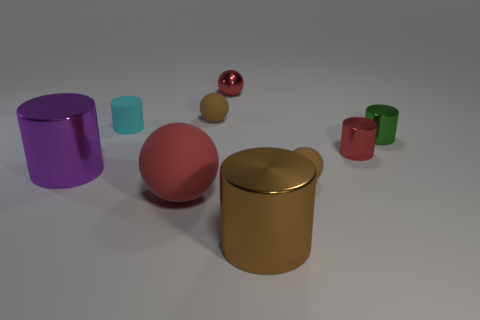Is there any other thing that is the same size as the green cylinder?
Keep it short and to the point. Yes. What size is the object that is both behind the tiny red metal cylinder and to the left of the large red matte thing?
Offer a very short reply. Small. What is the shape of the big brown thing that is made of the same material as the small green object?
Provide a short and direct response. Cylinder. Are the small green cylinder and the big thing that is left of the large ball made of the same material?
Your answer should be compact. Yes. Is there a small green metallic cylinder that is left of the small red thing left of the red cylinder?
Offer a very short reply. No. There is a red thing that is the same shape as the small green metal object; what material is it?
Offer a very short reply. Metal. There is a object on the right side of the tiny red shiny cylinder; what number of small red metallic spheres are right of it?
Provide a short and direct response. 0. Is there anything else of the same color as the large matte object?
Offer a very short reply. Yes. How many objects are big red cylinders or brown matte objects that are behind the purple cylinder?
Your answer should be very brief. 1. There is a object behind the small rubber sphere left of the small rubber thing in front of the purple metallic cylinder; what is its material?
Give a very brief answer. Metal. 